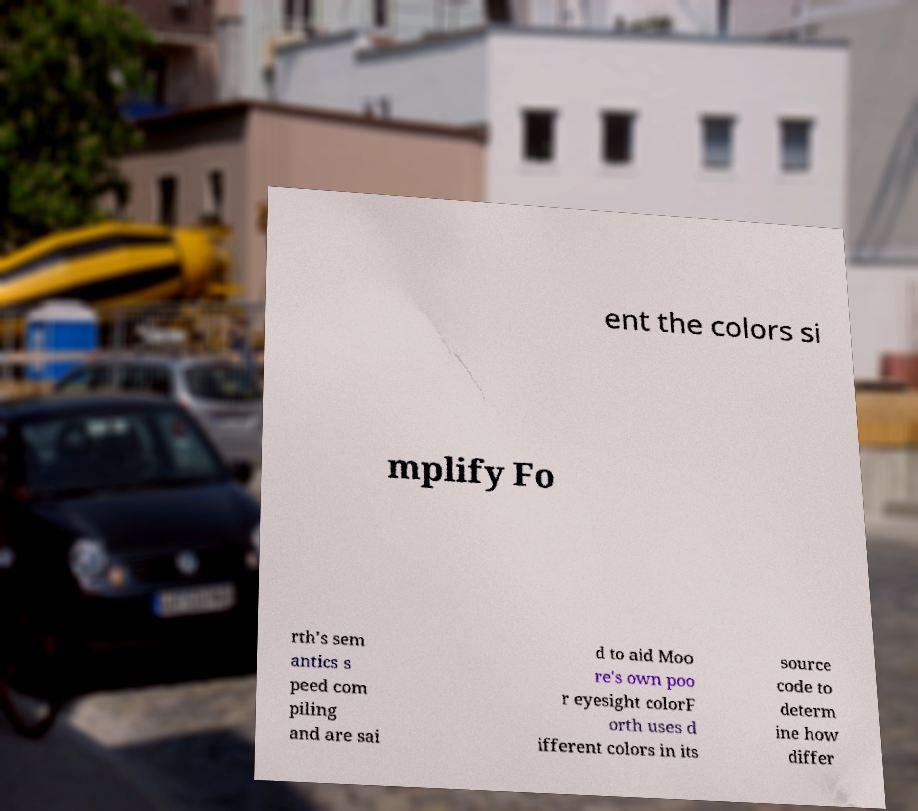Can you accurately transcribe the text from the provided image for me? ent the colors si mplify Fo rth's sem antics s peed com piling and are sai d to aid Moo re's own poo r eyesight colorF orth uses d ifferent colors in its source code to determ ine how differ 